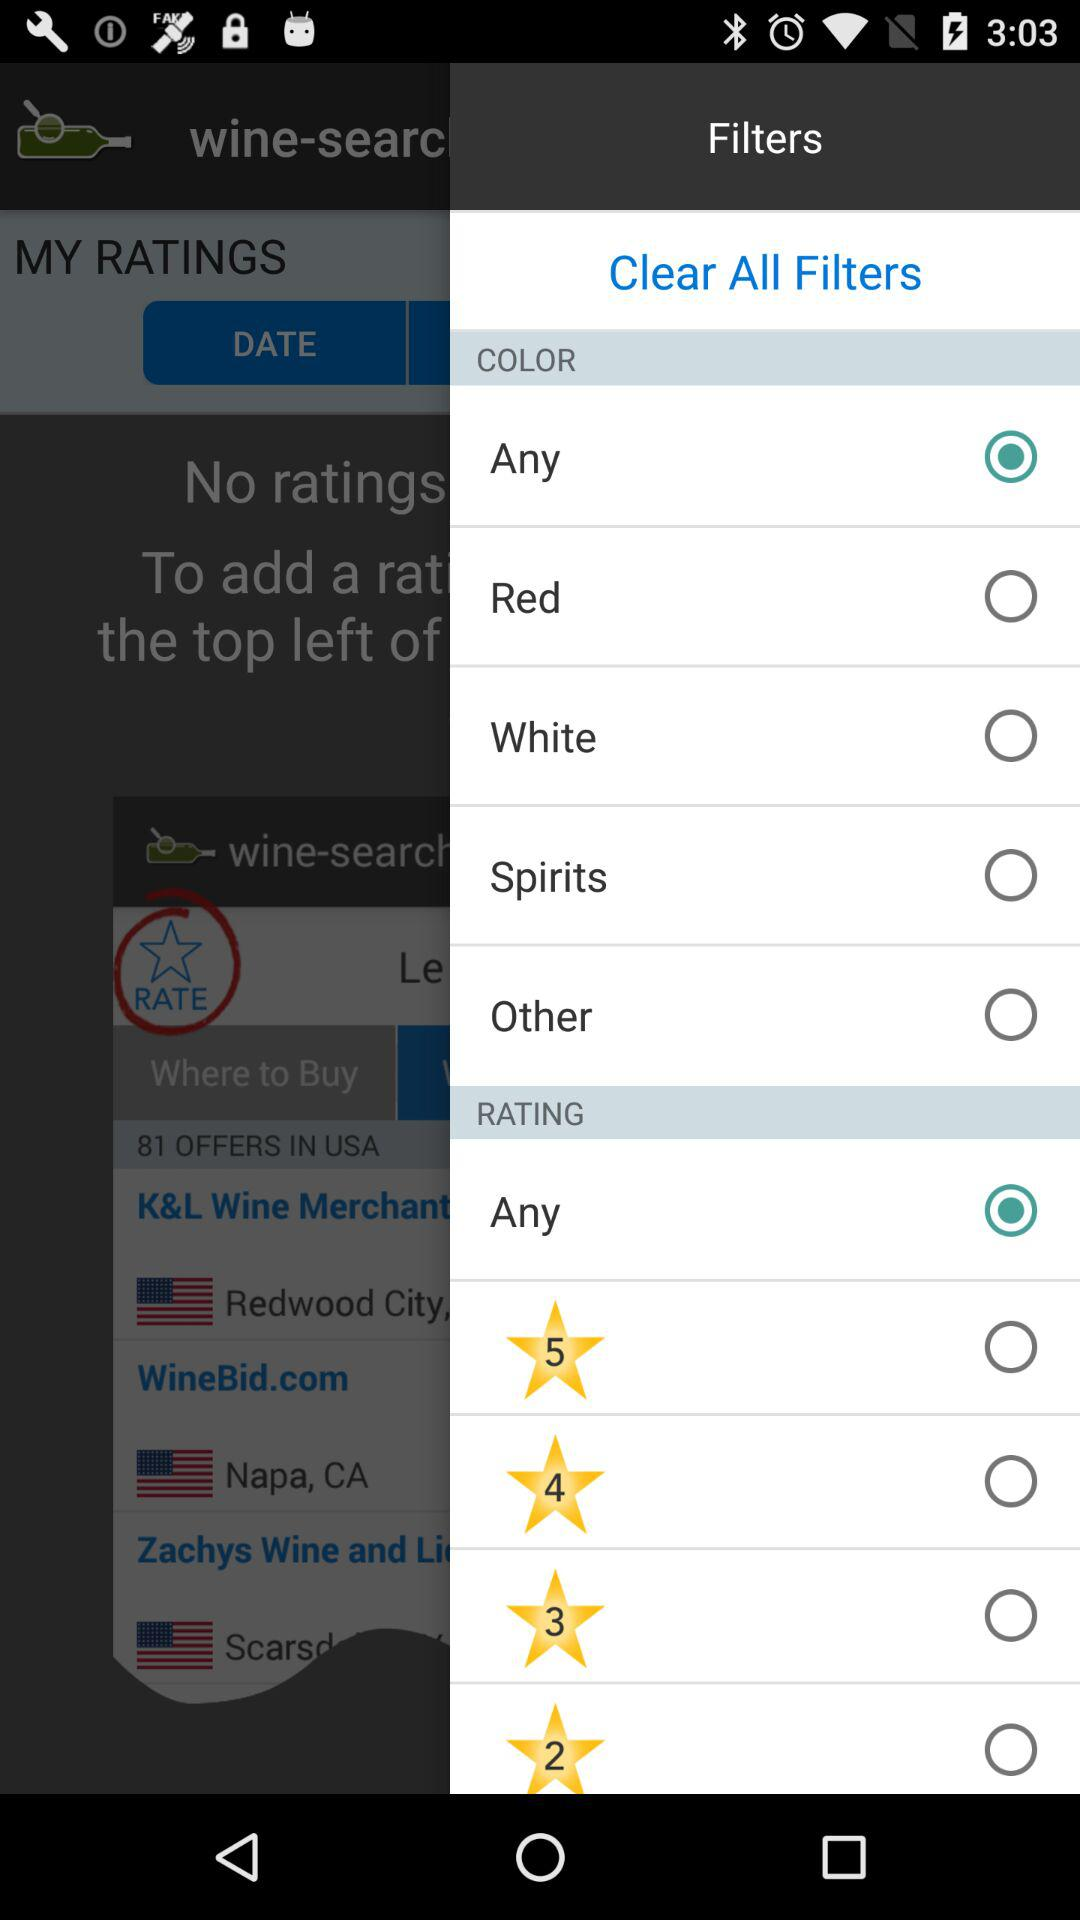How many followers are there?
When the provided information is insufficient, respond with <no answer>. <no answer> 